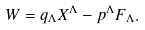<formula> <loc_0><loc_0><loc_500><loc_500>W = q _ { \Lambda } X ^ { \Lambda } - p ^ { \Lambda } F _ { \Lambda } .</formula> 